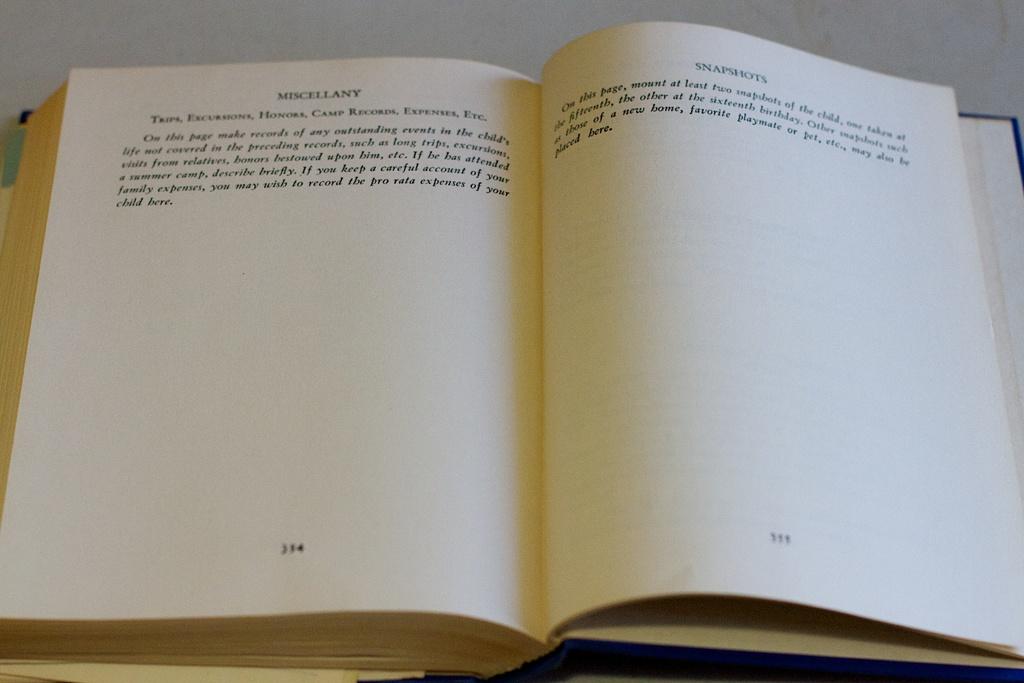Which page is about snapshots?
Your response must be concise. 335. What is the title on page 334?
Make the answer very short. Miscellany. 